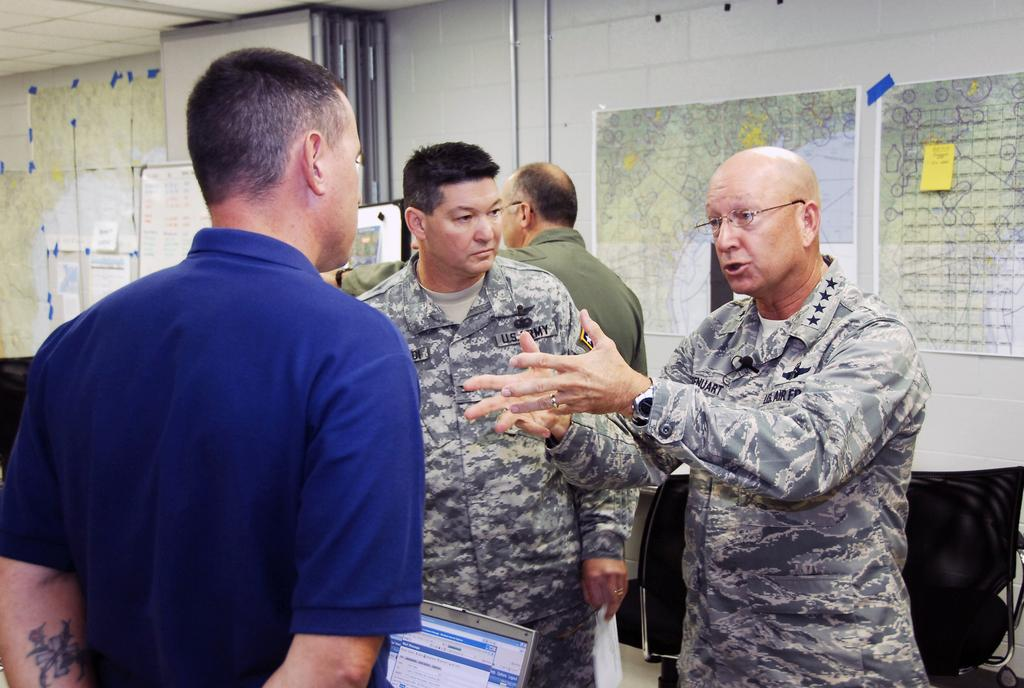What are the people in the image doing? The persons standing on the floor in the image are likely working or discussing something. What electronic device can be seen in the image? There is a laptop visible in the image. What type of infrastructure is present in the image? Pipelines are present in the image. What can be seen on the wall in the image? Maps are pasted on the wall in the image. What type of division is taking place in the image? There is no division taking place in the image; it simply shows people, a laptop, pipelines, and maps on the wall. What role does the zinc play in the image? There is no zinc present in the image. 